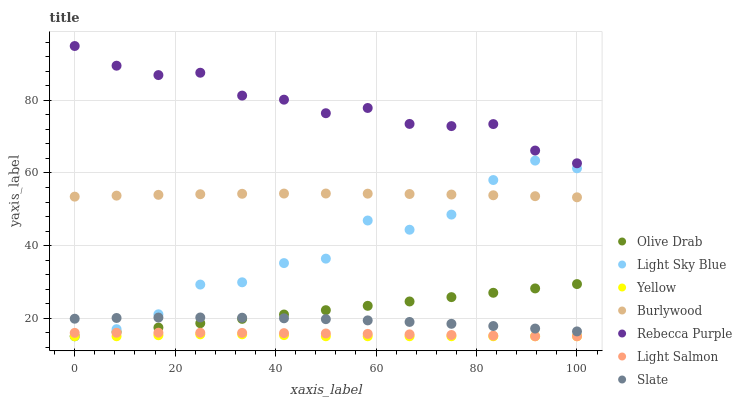Does Yellow have the minimum area under the curve?
Answer yes or no. Yes. Does Rebecca Purple have the maximum area under the curve?
Answer yes or no. Yes. Does Burlywood have the minimum area under the curve?
Answer yes or no. No. Does Burlywood have the maximum area under the curve?
Answer yes or no. No. Is Olive Drab the smoothest?
Answer yes or no. Yes. Is Light Sky Blue the roughest?
Answer yes or no. Yes. Is Burlywood the smoothest?
Answer yes or no. No. Is Burlywood the roughest?
Answer yes or no. No. Does Light Salmon have the lowest value?
Answer yes or no. Yes. Does Burlywood have the lowest value?
Answer yes or no. No. Does Rebecca Purple have the highest value?
Answer yes or no. Yes. Does Burlywood have the highest value?
Answer yes or no. No. Is Yellow less than Rebecca Purple?
Answer yes or no. Yes. Is Rebecca Purple greater than Light Sky Blue?
Answer yes or no. Yes. Does Light Sky Blue intersect Burlywood?
Answer yes or no. Yes. Is Light Sky Blue less than Burlywood?
Answer yes or no. No. Is Light Sky Blue greater than Burlywood?
Answer yes or no. No. Does Yellow intersect Rebecca Purple?
Answer yes or no. No. 